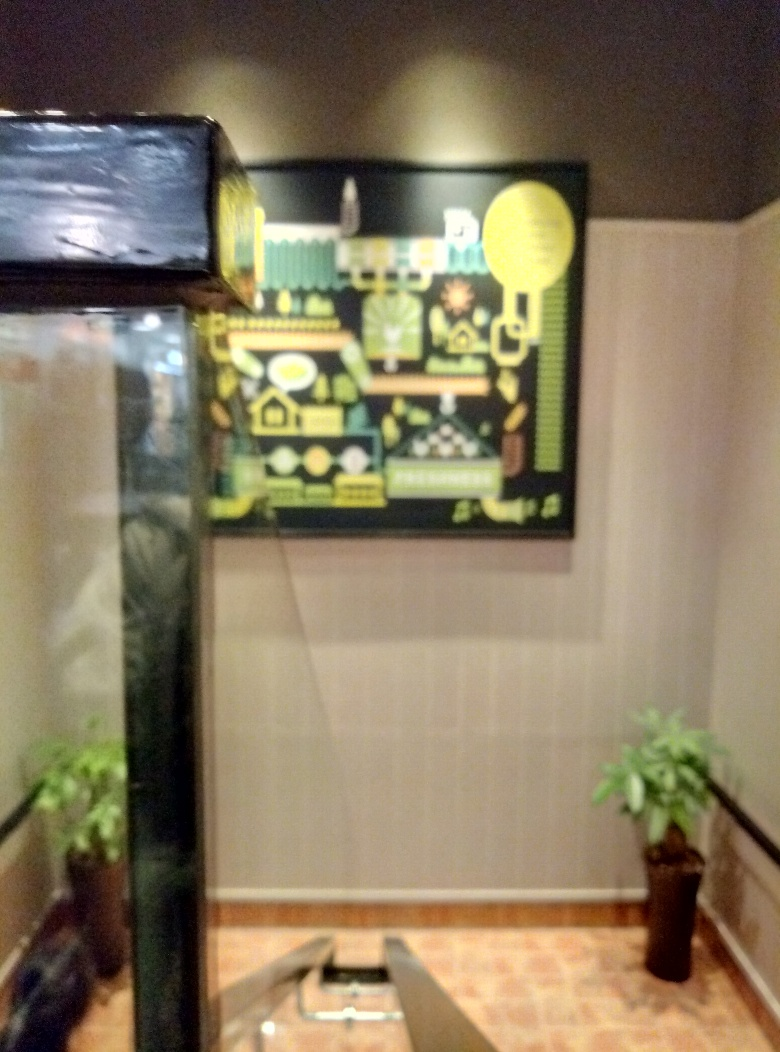What is the clarity of this image? The clarity of this image is quite poor. It's blurry and details are hard to discern, which could be due to camera shake, incorrect focus, or low lighting conditions when the photo was taken. 